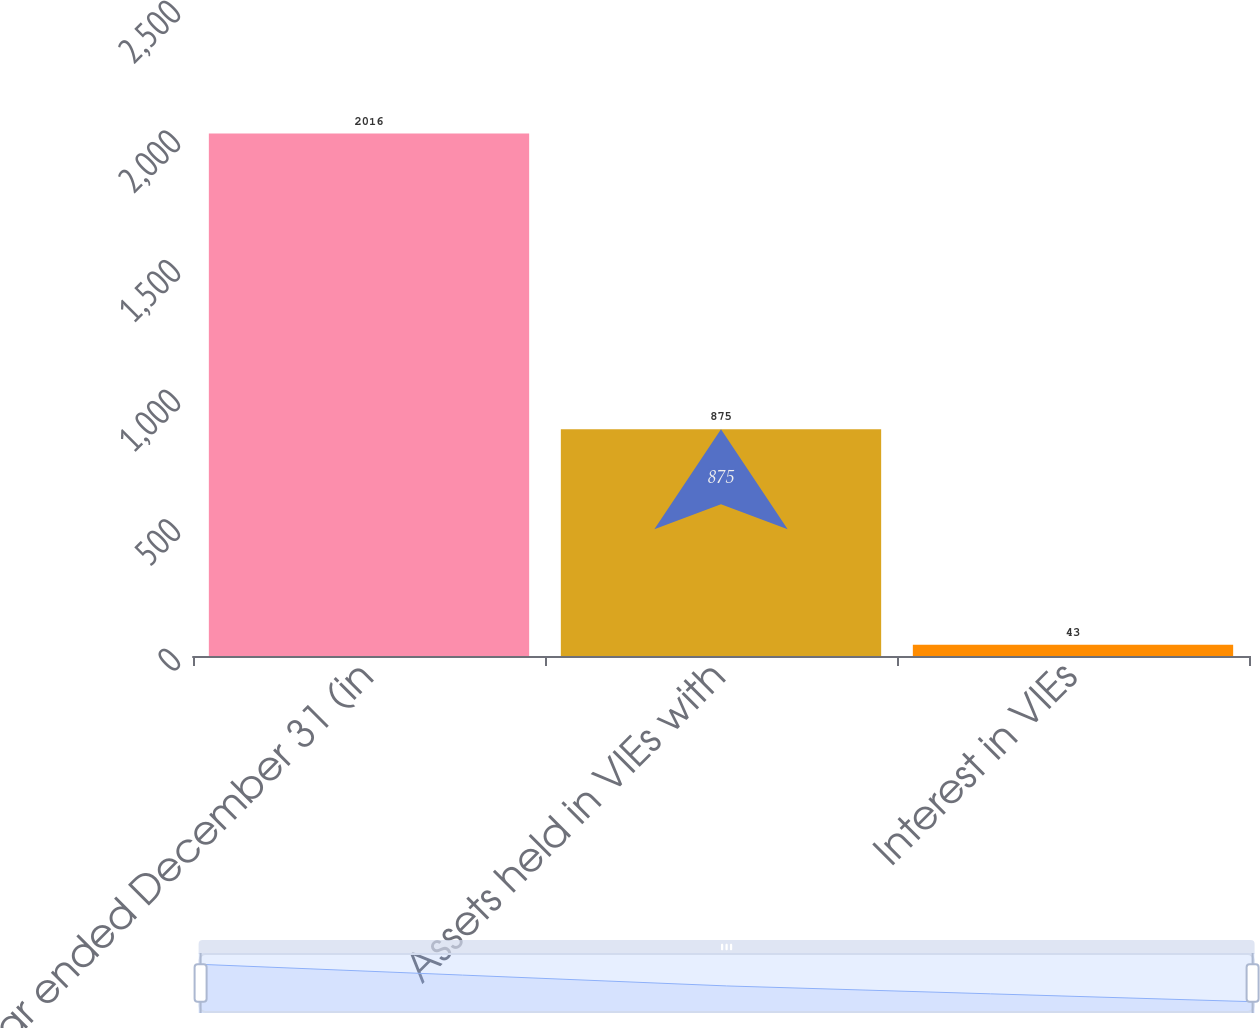Convert chart. <chart><loc_0><loc_0><loc_500><loc_500><bar_chart><fcel>Year ended December 31 (in<fcel>Assets held in VIEs with<fcel>Interest in VIEs<nl><fcel>2016<fcel>875<fcel>43<nl></chart> 